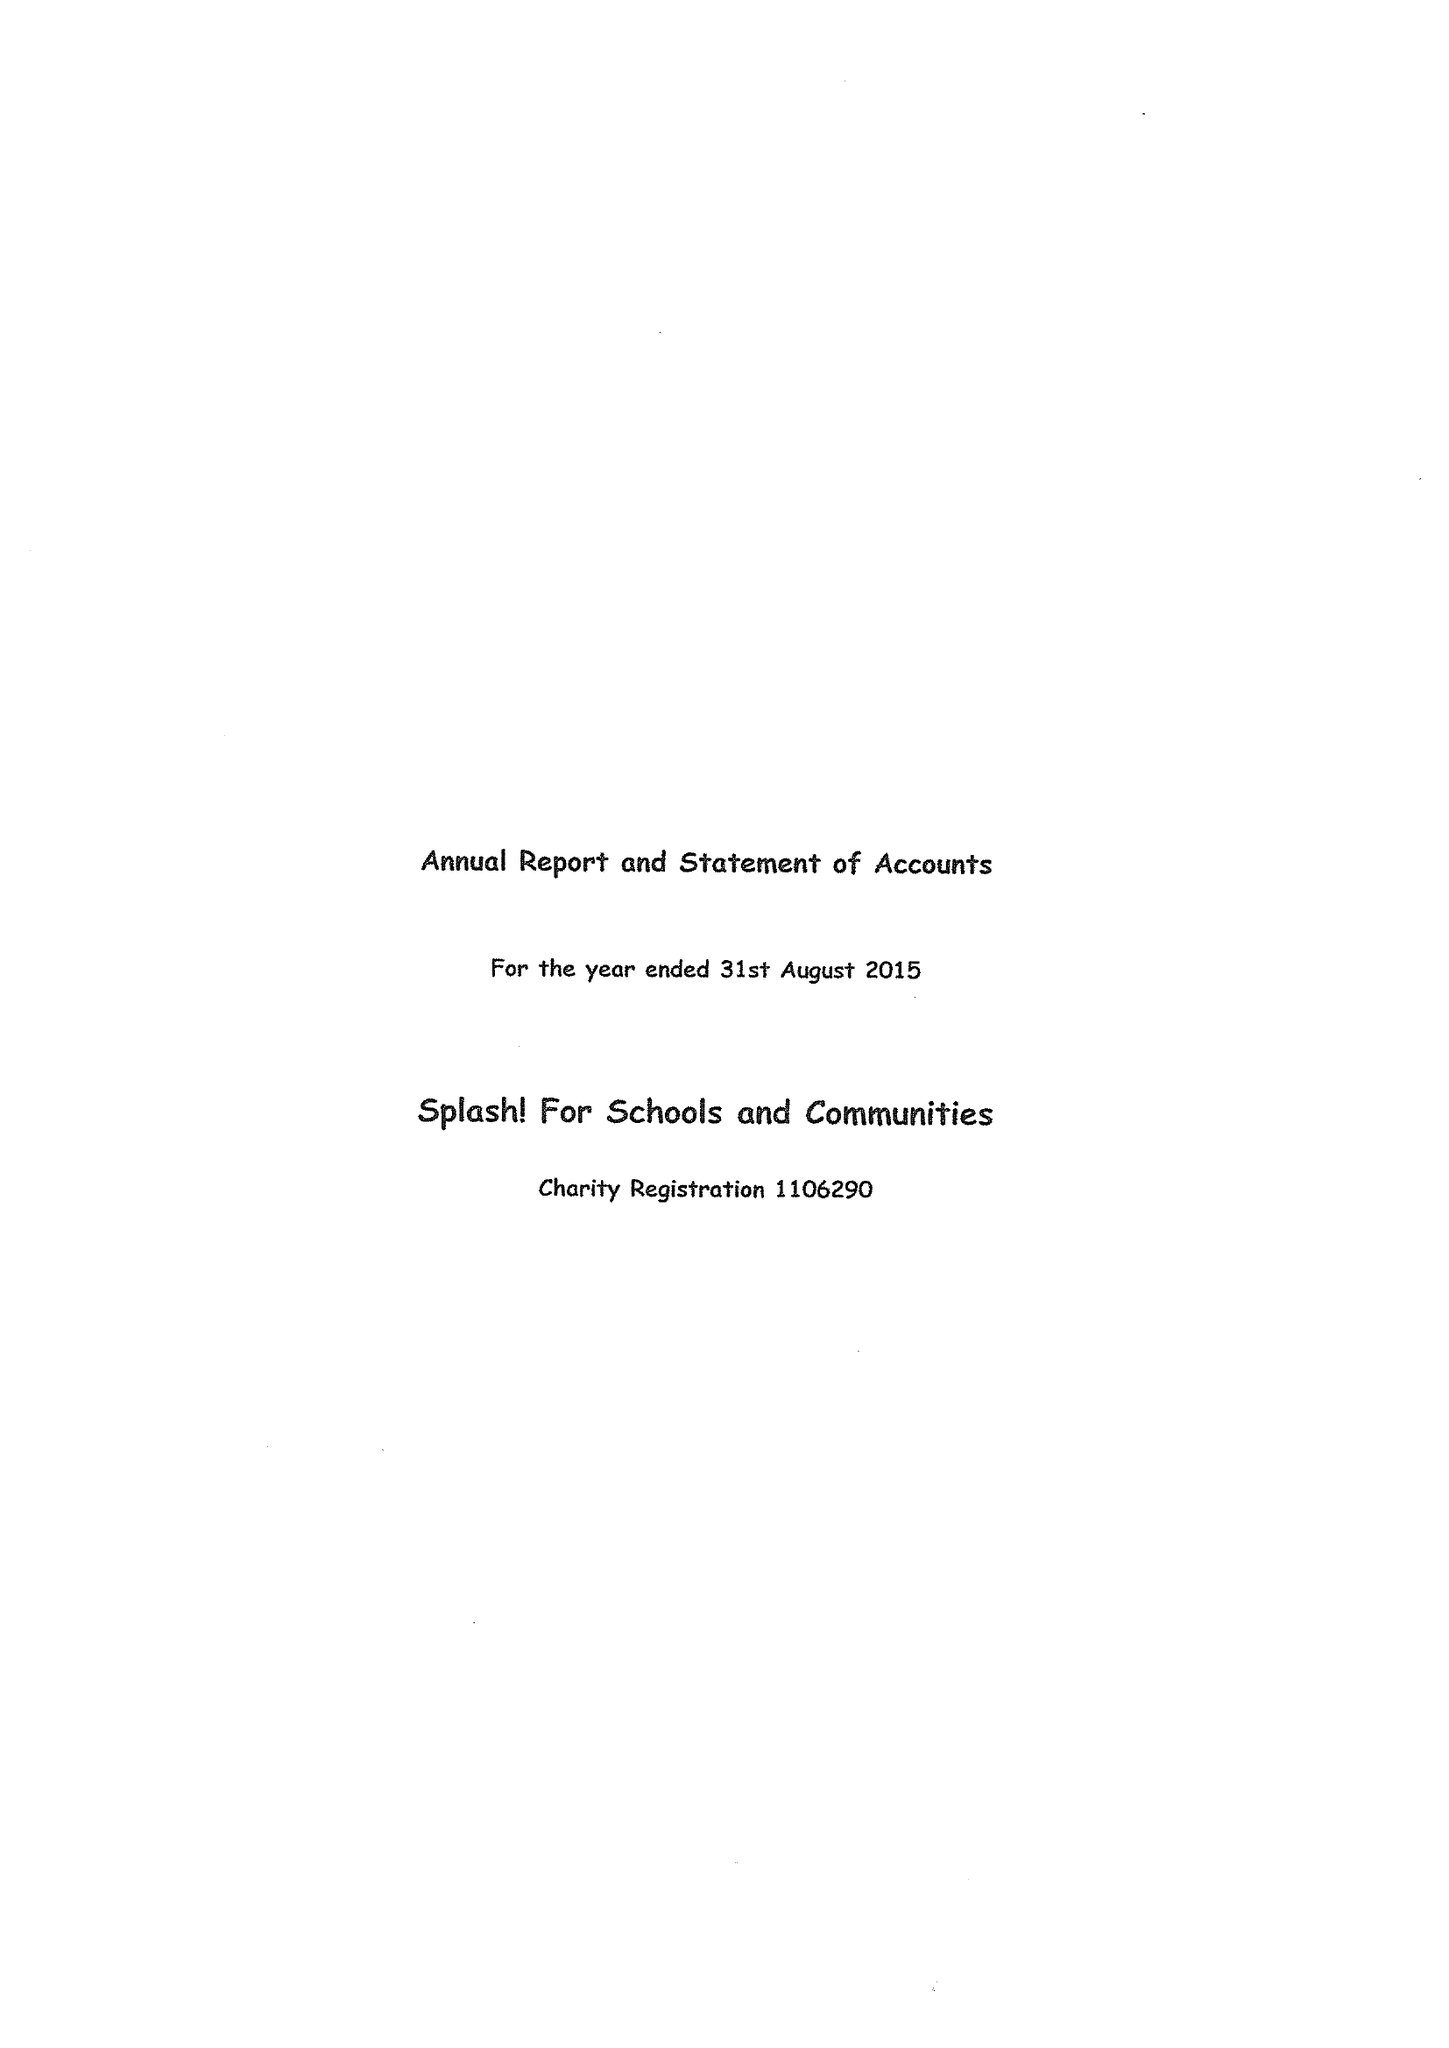What is the value for the spending_annually_in_british_pounds?
Answer the question using a single word or phrase. 60320.00 